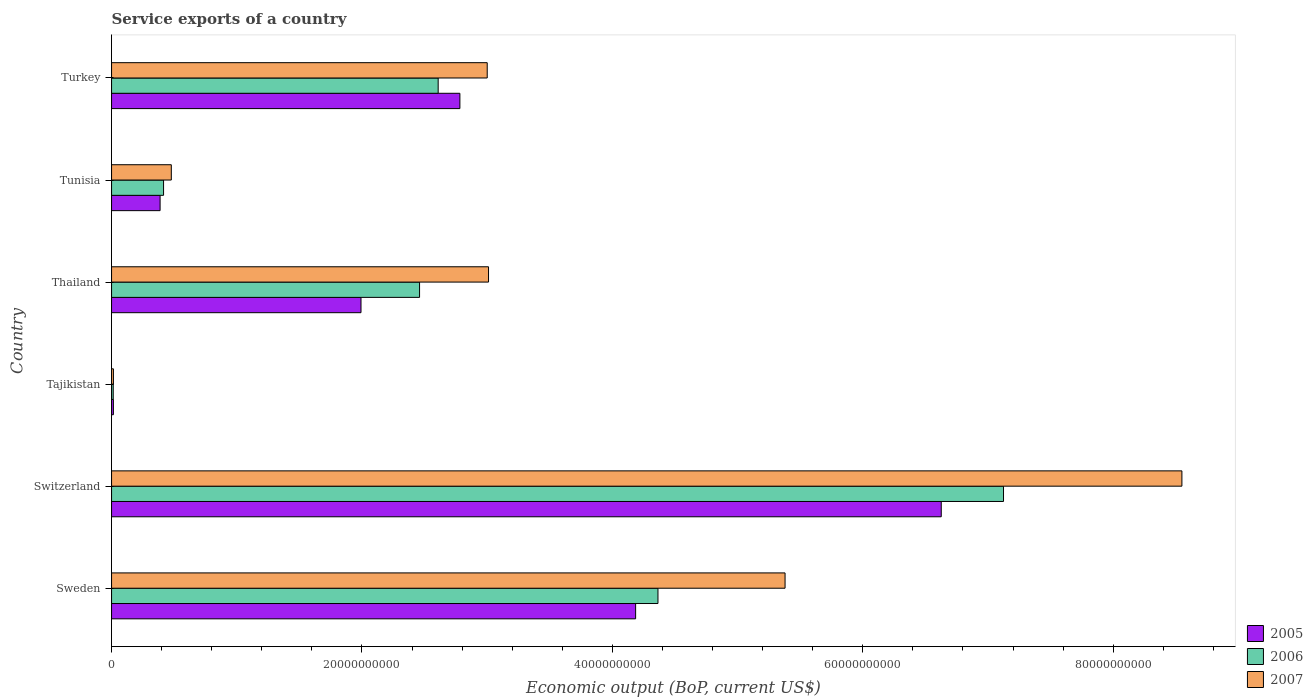How many groups of bars are there?
Give a very brief answer. 6. How many bars are there on the 5th tick from the top?
Keep it short and to the point. 3. What is the label of the 2nd group of bars from the top?
Provide a succinct answer. Tunisia. In how many cases, is the number of bars for a given country not equal to the number of legend labels?
Ensure brevity in your answer.  0. What is the service exports in 2006 in Thailand?
Offer a very short reply. 2.46e+1. Across all countries, what is the maximum service exports in 2006?
Your answer should be very brief. 7.12e+1. Across all countries, what is the minimum service exports in 2007?
Your answer should be very brief. 1.49e+08. In which country was the service exports in 2005 maximum?
Your answer should be compact. Switzerland. In which country was the service exports in 2007 minimum?
Your response must be concise. Tajikistan. What is the total service exports in 2006 in the graph?
Offer a terse response. 1.70e+11. What is the difference between the service exports in 2007 in Switzerland and that in Thailand?
Your response must be concise. 5.54e+1. What is the difference between the service exports in 2006 in Thailand and the service exports in 2007 in Tajikistan?
Give a very brief answer. 2.45e+1. What is the average service exports in 2006 per country?
Your answer should be very brief. 2.83e+1. What is the difference between the service exports in 2005 and service exports in 2006 in Tunisia?
Keep it short and to the point. -2.76e+08. In how many countries, is the service exports in 2005 greater than 28000000000 US$?
Give a very brief answer. 2. What is the ratio of the service exports in 2005 in Thailand to that in Turkey?
Your answer should be compact. 0.72. Is the service exports in 2007 in Tajikistan less than that in Tunisia?
Make the answer very short. Yes. Is the difference between the service exports in 2005 in Sweden and Tunisia greater than the difference between the service exports in 2006 in Sweden and Tunisia?
Offer a very short reply. No. What is the difference between the highest and the second highest service exports in 2005?
Your answer should be very brief. 2.44e+1. What is the difference between the highest and the lowest service exports in 2007?
Offer a terse response. 8.53e+1. In how many countries, is the service exports in 2006 greater than the average service exports in 2006 taken over all countries?
Your response must be concise. 2. What does the 2nd bar from the bottom in Sweden represents?
Give a very brief answer. 2006. Is it the case that in every country, the sum of the service exports in 2005 and service exports in 2007 is greater than the service exports in 2006?
Offer a very short reply. Yes. Does the graph contain grids?
Your answer should be very brief. No. How many legend labels are there?
Offer a terse response. 3. How are the legend labels stacked?
Give a very brief answer. Vertical. What is the title of the graph?
Offer a terse response. Service exports of a country. What is the label or title of the X-axis?
Ensure brevity in your answer.  Economic output (BoP, current US$). What is the label or title of the Y-axis?
Ensure brevity in your answer.  Country. What is the Economic output (BoP, current US$) of 2005 in Sweden?
Your answer should be compact. 4.19e+1. What is the Economic output (BoP, current US$) of 2006 in Sweden?
Provide a succinct answer. 4.36e+1. What is the Economic output (BoP, current US$) of 2007 in Sweden?
Give a very brief answer. 5.38e+1. What is the Economic output (BoP, current US$) of 2005 in Switzerland?
Offer a terse response. 6.63e+1. What is the Economic output (BoP, current US$) in 2006 in Switzerland?
Your response must be concise. 7.12e+1. What is the Economic output (BoP, current US$) in 2007 in Switzerland?
Your answer should be compact. 8.55e+1. What is the Economic output (BoP, current US$) of 2005 in Tajikistan?
Provide a succinct answer. 1.46e+08. What is the Economic output (BoP, current US$) in 2006 in Tajikistan?
Your response must be concise. 1.34e+08. What is the Economic output (BoP, current US$) in 2007 in Tajikistan?
Make the answer very short. 1.49e+08. What is the Economic output (BoP, current US$) of 2005 in Thailand?
Make the answer very short. 1.99e+1. What is the Economic output (BoP, current US$) of 2006 in Thailand?
Ensure brevity in your answer.  2.46e+1. What is the Economic output (BoP, current US$) of 2007 in Thailand?
Offer a terse response. 3.01e+1. What is the Economic output (BoP, current US$) in 2005 in Tunisia?
Give a very brief answer. 3.88e+09. What is the Economic output (BoP, current US$) in 2006 in Tunisia?
Ensure brevity in your answer.  4.15e+09. What is the Economic output (BoP, current US$) in 2007 in Tunisia?
Give a very brief answer. 4.77e+09. What is the Economic output (BoP, current US$) in 2005 in Turkey?
Ensure brevity in your answer.  2.78e+1. What is the Economic output (BoP, current US$) in 2006 in Turkey?
Your answer should be compact. 2.61e+1. What is the Economic output (BoP, current US$) in 2007 in Turkey?
Offer a very short reply. 3.00e+1. Across all countries, what is the maximum Economic output (BoP, current US$) of 2005?
Provide a succinct answer. 6.63e+1. Across all countries, what is the maximum Economic output (BoP, current US$) in 2006?
Offer a very short reply. 7.12e+1. Across all countries, what is the maximum Economic output (BoP, current US$) of 2007?
Ensure brevity in your answer.  8.55e+1. Across all countries, what is the minimum Economic output (BoP, current US$) of 2005?
Ensure brevity in your answer.  1.46e+08. Across all countries, what is the minimum Economic output (BoP, current US$) of 2006?
Provide a succinct answer. 1.34e+08. Across all countries, what is the minimum Economic output (BoP, current US$) of 2007?
Provide a succinct answer. 1.49e+08. What is the total Economic output (BoP, current US$) in 2005 in the graph?
Give a very brief answer. 1.60e+11. What is the total Economic output (BoP, current US$) in 2006 in the graph?
Offer a very short reply. 1.70e+11. What is the total Economic output (BoP, current US$) in 2007 in the graph?
Offer a terse response. 2.04e+11. What is the difference between the Economic output (BoP, current US$) in 2005 in Sweden and that in Switzerland?
Provide a short and direct response. -2.44e+1. What is the difference between the Economic output (BoP, current US$) in 2006 in Sweden and that in Switzerland?
Keep it short and to the point. -2.76e+1. What is the difference between the Economic output (BoP, current US$) of 2007 in Sweden and that in Switzerland?
Offer a very short reply. -3.17e+1. What is the difference between the Economic output (BoP, current US$) of 2005 in Sweden and that in Tajikistan?
Your answer should be very brief. 4.17e+1. What is the difference between the Economic output (BoP, current US$) of 2006 in Sweden and that in Tajikistan?
Offer a terse response. 4.35e+1. What is the difference between the Economic output (BoP, current US$) of 2007 in Sweden and that in Tajikistan?
Provide a succinct answer. 5.36e+1. What is the difference between the Economic output (BoP, current US$) of 2005 in Sweden and that in Thailand?
Your answer should be compact. 2.19e+1. What is the difference between the Economic output (BoP, current US$) of 2006 in Sweden and that in Thailand?
Your answer should be very brief. 1.90e+1. What is the difference between the Economic output (BoP, current US$) of 2007 in Sweden and that in Thailand?
Your answer should be very brief. 2.37e+1. What is the difference between the Economic output (BoP, current US$) of 2005 in Sweden and that in Tunisia?
Give a very brief answer. 3.80e+1. What is the difference between the Economic output (BoP, current US$) in 2006 in Sweden and that in Tunisia?
Make the answer very short. 3.95e+1. What is the difference between the Economic output (BoP, current US$) of 2007 in Sweden and that in Tunisia?
Make the answer very short. 4.90e+1. What is the difference between the Economic output (BoP, current US$) in 2005 in Sweden and that in Turkey?
Provide a succinct answer. 1.40e+1. What is the difference between the Economic output (BoP, current US$) of 2006 in Sweden and that in Turkey?
Offer a very short reply. 1.76e+1. What is the difference between the Economic output (BoP, current US$) of 2007 in Sweden and that in Turkey?
Your response must be concise. 2.38e+1. What is the difference between the Economic output (BoP, current US$) in 2005 in Switzerland and that in Tajikistan?
Give a very brief answer. 6.61e+1. What is the difference between the Economic output (BoP, current US$) in 2006 in Switzerland and that in Tajikistan?
Your answer should be very brief. 7.11e+1. What is the difference between the Economic output (BoP, current US$) in 2007 in Switzerland and that in Tajikistan?
Make the answer very short. 8.53e+1. What is the difference between the Economic output (BoP, current US$) of 2005 in Switzerland and that in Thailand?
Make the answer very short. 4.63e+1. What is the difference between the Economic output (BoP, current US$) in 2006 in Switzerland and that in Thailand?
Keep it short and to the point. 4.66e+1. What is the difference between the Economic output (BoP, current US$) in 2007 in Switzerland and that in Thailand?
Offer a terse response. 5.54e+1. What is the difference between the Economic output (BoP, current US$) of 2005 in Switzerland and that in Tunisia?
Offer a terse response. 6.24e+1. What is the difference between the Economic output (BoP, current US$) in 2006 in Switzerland and that in Tunisia?
Offer a terse response. 6.71e+1. What is the difference between the Economic output (BoP, current US$) in 2007 in Switzerland and that in Tunisia?
Give a very brief answer. 8.07e+1. What is the difference between the Economic output (BoP, current US$) of 2005 in Switzerland and that in Turkey?
Your response must be concise. 3.84e+1. What is the difference between the Economic output (BoP, current US$) of 2006 in Switzerland and that in Turkey?
Offer a very short reply. 4.52e+1. What is the difference between the Economic output (BoP, current US$) of 2007 in Switzerland and that in Turkey?
Your answer should be very brief. 5.55e+1. What is the difference between the Economic output (BoP, current US$) of 2005 in Tajikistan and that in Thailand?
Provide a succinct answer. -1.98e+1. What is the difference between the Economic output (BoP, current US$) in 2006 in Tajikistan and that in Thailand?
Offer a terse response. -2.45e+1. What is the difference between the Economic output (BoP, current US$) in 2007 in Tajikistan and that in Thailand?
Offer a very short reply. -3.00e+1. What is the difference between the Economic output (BoP, current US$) of 2005 in Tajikistan and that in Tunisia?
Provide a succinct answer. -3.73e+09. What is the difference between the Economic output (BoP, current US$) in 2006 in Tajikistan and that in Tunisia?
Ensure brevity in your answer.  -4.02e+09. What is the difference between the Economic output (BoP, current US$) in 2007 in Tajikistan and that in Tunisia?
Keep it short and to the point. -4.62e+09. What is the difference between the Economic output (BoP, current US$) in 2005 in Tajikistan and that in Turkey?
Your response must be concise. -2.77e+1. What is the difference between the Economic output (BoP, current US$) in 2006 in Tajikistan and that in Turkey?
Offer a terse response. -2.60e+1. What is the difference between the Economic output (BoP, current US$) in 2007 in Tajikistan and that in Turkey?
Offer a very short reply. -2.99e+1. What is the difference between the Economic output (BoP, current US$) in 2005 in Thailand and that in Tunisia?
Ensure brevity in your answer.  1.60e+1. What is the difference between the Economic output (BoP, current US$) of 2006 in Thailand and that in Tunisia?
Give a very brief answer. 2.04e+1. What is the difference between the Economic output (BoP, current US$) in 2007 in Thailand and that in Tunisia?
Ensure brevity in your answer.  2.53e+1. What is the difference between the Economic output (BoP, current US$) in 2005 in Thailand and that in Turkey?
Keep it short and to the point. -7.90e+09. What is the difference between the Economic output (BoP, current US$) of 2006 in Thailand and that in Turkey?
Provide a succinct answer. -1.49e+09. What is the difference between the Economic output (BoP, current US$) of 2007 in Thailand and that in Turkey?
Your response must be concise. 1.05e+08. What is the difference between the Economic output (BoP, current US$) of 2005 in Tunisia and that in Turkey?
Offer a terse response. -2.39e+1. What is the difference between the Economic output (BoP, current US$) of 2006 in Tunisia and that in Turkey?
Keep it short and to the point. -2.19e+1. What is the difference between the Economic output (BoP, current US$) of 2007 in Tunisia and that in Turkey?
Offer a very short reply. -2.52e+1. What is the difference between the Economic output (BoP, current US$) of 2005 in Sweden and the Economic output (BoP, current US$) of 2006 in Switzerland?
Give a very brief answer. -2.94e+1. What is the difference between the Economic output (BoP, current US$) in 2005 in Sweden and the Economic output (BoP, current US$) in 2007 in Switzerland?
Your response must be concise. -4.36e+1. What is the difference between the Economic output (BoP, current US$) of 2006 in Sweden and the Economic output (BoP, current US$) of 2007 in Switzerland?
Keep it short and to the point. -4.18e+1. What is the difference between the Economic output (BoP, current US$) in 2005 in Sweden and the Economic output (BoP, current US$) in 2006 in Tajikistan?
Offer a terse response. 4.17e+1. What is the difference between the Economic output (BoP, current US$) of 2005 in Sweden and the Economic output (BoP, current US$) of 2007 in Tajikistan?
Provide a succinct answer. 4.17e+1. What is the difference between the Economic output (BoP, current US$) in 2006 in Sweden and the Economic output (BoP, current US$) in 2007 in Tajikistan?
Make the answer very short. 4.35e+1. What is the difference between the Economic output (BoP, current US$) of 2005 in Sweden and the Economic output (BoP, current US$) of 2006 in Thailand?
Provide a short and direct response. 1.73e+1. What is the difference between the Economic output (BoP, current US$) of 2005 in Sweden and the Economic output (BoP, current US$) of 2007 in Thailand?
Provide a short and direct response. 1.17e+1. What is the difference between the Economic output (BoP, current US$) in 2006 in Sweden and the Economic output (BoP, current US$) in 2007 in Thailand?
Offer a very short reply. 1.35e+1. What is the difference between the Economic output (BoP, current US$) of 2005 in Sweden and the Economic output (BoP, current US$) of 2006 in Tunisia?
Offer a very short reply. 3.77e+1. What is the difference between the Economic output (BoP, current US$) of 2005 in Sweden and the Economic output (BoP, current US$) of 2007 in Tunisia?
Provide a succinct answer. 3.71e+1. What is the difference between the Economic output (BoP, current US$) of 2006 in Sweden and the Economic output (BoP, current US$) of 2007 in Tunisia?
Your answer should be compact. 3.89e+1. What is the difference between the Economic output (BoP, current US$) of 2005 in Sweden and the Economic output (BoP, current US$) of 2006 in Turkey?
Ensure brevity in your answer.  1.58e+1. What is the difference between the Economic output (BoP, current US$) of 2005 in Sweden and the Economic output (BoP, current US$) of 2007 in Turkey?
Ensure brevity in your answer.  1.19e+1. What is the difference between the Economic output (BoP, current US$) of 2006 in Sweden and the Economic output (BoP, current US$) of 2007 in Turkey?
Ensure brevity in your answer.  1.36e+1. What is the difference between the Economic output (BoP, current US$) in 2005 in Switzerland and the Economic output (BoP, current US$) in 2006 in Tajikistan?
Ensure brevity in your answer.  6.61e+1. What is the difference between the Economic output (BoP, current US$) of 2005 in Switzerland and the Economic output (BoP, current US$) of 2007 in Tajikistan?
Your answer should be very brief. 6.61e+1. What is the difference between the Economic output (BoP, current US$) in 2006 in Switzerland and the Economic output (BoP, current US$) in 2007 in Tajikistan?
Your answer should be very brief. 7.11e+1. What is the difference between the Economic output (BoP, current US$) in 2005 in Switzerland and the Economic output (BoP, current US$) in 2006 in Thailand?
Your answer should be very brief. 4.17e+1. What is the difference between the Economic output (BoP, current US$) of 2005 in Switzerland and the Economic output (BoP, current US$) of 2007 in Thailand?
Ensure brevity in your answer.  3.62e+1. What is the difference between the Economic output (BoP, current US$) in 2006 in Switzerland and the Economic output (BoP, current US$) in 2007 in Thailand?
Your response must be concise. 4.11e+1. What is the difference between the Economic output (BoP, current US$) of 2005 in Switzerland and the Economic output (BoP, current US$) of 2006 in Tunisia?
Provide a succinct answer. 6.21e+1. What is the difference between the Economic output (BoP, current US$) in 2005 in Switzerland and the Economic output (BoP, current US$) in 2007 in Tunisia?
Ensure brevity in your answer.  6.15e+1. What is the difference between the Economic output (BoP, current US$) in 2006 in Switzerland and the Economic output (BoP, current US$) in 2007 in Tunisia?
Ensure brevity in your answer.  6.65e+1. What is the difference between the Economic output (BoP, current US$) in 2005 in Switzerland and the Economic output (BoP, current US$) in 2006 in Turkey?
Your answer should be very brief. 4.02e+1. What is the difference between the Economic output (BoP, current US$) of 2005 in Switzerland and the Economic output (BoP, current US$) of 2007 in Turkey?
Give a very brief answer. 3.63e+1. What is the difference between the Economic output (BoP, current US$) in 2006 in Switzerland and the Economic output (BoP, current US$) in 2007 in Turkey?
Offer a terse response. 4.12e+1. What is the difference between the Economic output (BoP, current US$) of 2005 in Tajikistan and the Economic output (BoP, current US$) of 2006 in Thailand?
Keep it short and to the point. -2.45e+1. What is the difference between the Economic output (BoP, current US$) of 2005 in Tajikistan and the Economic output (BoP, current US$) of 2007 in Thailand?
Give a very brief answer. -3.00e+1. What is the difference between the Economic output (BoP, current US$) in 2006 in Tajikistan and the Economic output (BoP, current US$) in 2007 in Thailand?
Offer a terse response. -3.00e+1. What is the difference between the Economic output (BoP, current US$) of 2005 in Tajikistan and the Economic output (BoP, current US$) of 2006 in Tunisia?
Provide a short and direct response. -4.01e+09. What is the difference between the Economic output (BoP, current US$) of 2005 in Tajikistan and the Economic output (BoP, current US$) of 2007 in Tunisia?
Provide a succinct answer. -4.63e+09. What is the difference between the Economic output (BoP, current US$) of 2006 in Tajikistan and the Economic output (BoP, current US$) of 2007 in Tunisia?
Provide a succinct answer. -4.64e+09. What is the difference between the Economic output (BoP, current US$) in 2005 in Tajikistan and the Economic output (BoP, current US$) in 2006 in Turkey?
Provide a succinct answer. -2.59e+1. What is the difference between the Economic output (BoP, current US$) in 2005 in Tajikistan and the Economic output (BoP, current US$) in 2007 in Turkey?
Ensure brevity in your answer.  -2.99e+1. What is the difference between the Economic output (BoP, current US$) of 2006 in Tajikistan and the Economic output (BoP, current US$) of 2007 in Turkey?
Offer a terse response. -2.99e+1. What is the difference between the Economic output (BoP, current US$) of 2005 in Thailand and the Economic output (BoP, current US$) of 2006 in Tunisia?
Keep it short and to the point. 1.58e+1. What is the difference between the Economic output (BoP, current US$) in 2005 in Thailand and the Economic output (BoP, current US$) in 2007 in Tunisia?
Give a very brief answer. 1.52e+1. What is the difference between the Economic output (BoP, current US$) of 2006 in Thailand and the Economic output (BoP, current US$) of 2007 in Tunisia?
Provide a succinct answer. 1.98e+1. What is the difference between the Economic output (BoP, current US$) of 2005 in Thailand and the Economic output (BoP, current US$) of 2006 in Turkey?
Keep it short and to the point. -6.16e+09. What is the difference between the Economic output (BoP, current US$) in 2005 in Thailand and the Economic output (BoP, current US$) in 2007 in Turkey?
Ensure brevity in your answer.  -1.01e+1. What is the difference between the Economic output (BoP, current US$) of 2006 in Thailand and the Economic output (BoP, current US$) of 2007 in Turkey?
Make the answer very short. -5.40e+09. What is the difference between the Economic output (BoP, current US$) of 2005 in Tunisia and the Economic output (BoP, current US$) of 2006 in Turkey?
Offer a very short reply. -2.22e+1. What is the difference between the Economic output (BoP, current US$) of 2005 in Tunisia and the Economic output (BoP, current US$) of 2007 in Turkey?
Your answer should be compact. -2.61e+1. What is the difference between the Economic output (BoP, current US$) in 2006 in Tunisia and the Economic output (BoP, current US$) in 2007 in Turkey?
Provide a succinct answer. -2.59e+1. What is the average Economic output (BoP, current US$) in 2005 per country?
Keep it short and to the point. 2.66e+1. What is the average Economic output (BoP, current US$) of 2006 per country?
Give a very brief answer. 2.83e+1. What is the average Economic output (BoP, current US$) of 2007 per country?
Offer a very short reply. 3.41e+1. What is the difference between the Economic output (BoP, current US$) of 2005 and Economic output (BoP, current US$) of 2006 in Sweden?
Ensure brevity in your answer.  -1.78e+09. What is the difference between the Economic output (BoP, current US$) of 2005 and Economic output (BoP, current US$) of 2007 in Sweden?
Provide a short and direct response. -1.19e+1. What is the difference between the Economic output (BoP, current US$) of 2006 and Economic output (BoP, current US$) of 2007 in Sweden?
Ensure brevity in your answer.  -1.02e+1. What is the difference between the Economic output (BoP, current US$) in 2005 and Economic output (BoP, current US$) in 2006 in Switzerland?
Your answer should be compact. -4.97e+09. What is the difference between the Economic output (BoP, current US$) of 2005 and Economic output (BoP, current US$) of 2007 in Switzerland?
Your answer should be compact. -1.92e+1. What is the difference between the Economic output (BoP, current US$) in 2006 and Economic output (BoP, current US$) in 2007 in Switzerland?
Keep it short and to the point. -1.42e+1. What is the difference between the Economic output (BoP, current US$) in 2005 and Economic output (BoP, current US$) in 2006 in Tajikistan?
Give a very brief answer. 1.21e+07. What is the difference between the Economic output (BoP, current US$) of 2005 and Economic output (BoP, current US$) of 2007 in Tajikistan?
Offer a terse response. -2.35e+06. What is the difference between the Economic output (BoP, current US$) of 2006 and Economic output (BoP, current US$) of 2007 in Tajikistan?
Keep it short and to the point. -1.45e+07. What is the difference between the Economic output (BoP, current US$) in 2005 and Economic output (BoP, current US$) in 2006 in Thailand?
Your answer should be compact. -4.68e+09. What is the difference between the Economic output (BoP, current US$) in 2005 and Economic output (BoP, current US$) in 2007 in Thailand?
Your response must be concise. -1.02e+1. What is the difference between the Economic output (BoP, current US$) in 2006 and Economic output (BoP, current US$) in 2007 in Thailand?
Your response must be concise. -5.51e+09. What is the difference between the Economic output (BoP, current US$) in 2005 and Economic output (BoP, current US$) in 2006 in Tunisia?
Your response must be concise. -2.76e+08. What is the difference between the Economic output (BoP, current US$) of 2005 and Economic output (BoP, current US$) of 2007 in Tunisia?
Make the answer very short. -8.95e+08. What is the difference between the Economic output (BoP, current US$) in 2006 and Economic output (BoP, current US$) in 2007 in Tunisia?
Ensure brevity in your answer.  -6.19e+08. What is the difference between the Economic output (BoP, current US$) in 2005 and Economic output (BoP, current US$) in 2006 in Turkey?
Provide a succinct answer. 1.74e+09. What is the difference between the Economic output (BoP, current US$) in 2005 and Economic output (BoP, current US$) in 2007 in Turkey?
Your answer should be very brief. -2.18e+09. What is the difference between the Economic output (BoP, current US$) of 2006 and Economic output (BoP, current US$) of 2007 in Turkey?
Provide a succinct answer. -3.92e+09. What is the ratio of the Economic output (BoP, current US$) in 2005 in Sweden to that in Switzerland?
Offer a very short reply. 0.63. What is the ratio of the Economic output (BoP, current US$) in 2006 in Sweden to that in Switzerland?
Make the answer very short. 0.61. What is the ratio of the Economic output (BoP, current US$) in 2007 in Sweden to that in Switzerland?
Give a very brief answer. 0.63. What is the ratio of the Economic output (BoP, current US$) in 2005 in Sweden to that in Tajikistan?
Your answer should be very brief. 286.03. What is the ratio of the Economic output (BoP, current US$) in 2006 in Sweden to that in Tajikistan?
Provide a short and direct response. 325.17. What is the ratio of the Economic output (BoP, current US$) of 2007 in Sweden to that in Tajikistan?
Provide a succinct answer. 361.78. What is the ratio of the Economic output (BoP, current US$) of 2005 in Sweden to that in Thailand?
Offer a very short reply. 2.1. What is the ratio of the Economic output (BoP, current US$) of 2006 in Sweden to that in Thailand?
Provide a succinct answer. 1.77. What is the ratio of the Economic output (BoP, current US$) of 2007 in Sweden to that in Thailand?
Provide a short and direct response. 1.79. What is the ratio of the Economic output (BoP, current US$) of 2005 in Sweden to that in Tunisia?
Provide a succinct answer. 10.8. What is the ratio of the Economic output (BoP, current US$) in 2006 in Sweden to that in Tunisia?
Offer a terse response. 10.51. What is the ratio of the Economic output (BoP, current US$) of 2007 in Sweden to that in Tunisia?
Your answer should be compact. 11.27. What is the ratio of the Economic output (BoP, current US$) of 2005 in Sweden to that in Turkey?
Provide a succinct answer. 1.5. What is the ratio of the Economic output (BoP, current US$) in 2006 in Sweden to that in Turkey?
Provide a short and direct response. 1.67. What is the ratio of the Economic output (BoP, current US$) of 2007 in Sweden to that in Turkey?
Offer a very short reply. 1.79. What is the ratio of the Economic output (BoP, current US$) of 2005 in Switzerland to that in Tajikistan?
Your response must be concise. 452.84. What is the ratio of the Economic output (BoP, current US$) in 2006 in Switzerland to that in Tajikistan?
Ensure brevity in your answer.  530.8. What is the ratio of the Economic output (BoP, current US$) in 2007 in Switzerland to that in Tajikistan?
Your response must be concise. 574.95. What is the ratio of the Economic output (BoP, current US$) in 2005 in Switzerland to that in Thailand?
Offer a very short reply. 3.33. What is the ratio of the Economic output (BoP, current US$) of 2006 in Switzerland to that in Thailand?
Keep it short and to the point. 2.9. What is the ratio of the Economic output (BoP, current US$) in 2007 in Switzerland to that in Thailand?
Provide a succinct answer. 2.84. What is the ratio of the Economic output (BoP, current US$) in 2005 in Switzerland to that in Tunisia?
Provide a short and direct response. 17.09. What is the ratio of the Economic output (BoP, current US$) of 2006 in Switzerland to that in Tunisia?
Make the answer very short. 17.15. What is the ratio of the Economic output (BoP, current US$) in 2007 in Switzerland to that in Tunisia?
Make the answer very short. 17.91. What is the ratio of the Economic output (BoP, current US$) in 2005 in Switzerland to that in Turkey?
Offer a very short reply. 2.38. What is the ratio of the Economic output (BoP, current US$) in 2006 in Switzerland to that in Turkey?
Ensure brevity in your answer.  2.73. What is the ratio of the Economic output (BoP, current US$) in 2007 in Switzerland to that in Turkey?
Keep it short and to the point. 2.85. What is the ratio of the Economic output (BoP, current US$) in 2005 in Tajikistan to that in Thailand?
Keep it short and to the point. 0.01. What is the ratio of the Economic output (BoP, current US$) of 2006 in Tajikistan to that in Thailand?
Provide a succinct answer. 0.01. What is the ratio of the Economic output (BoP, current US$) in 2007 in Tajikistan to that in Thailand?
Give a very brief answer. 0. What is the ratio of the Economic output (BoP, current US$) in 2005 in Tajikistan to that in Tunisia?
Keep it short and to the point. 0.04. What is the ratio of the Economic output (BoP, current US$) in 2006 in Tajikistan to that in Tunisia?
Give a very brief answer. 0.03. What is the ratio of the Economic output (BoP, current US$) in 2007 in Tajikistan to that in Tunisia?
Ensure brevity in your answer.  0.03. What is the ratio of the Economic output (BoP, current US$) in 2005 in Tajikistan to that in Turkey?
Ensure brevity in your answer.  0.01. What is the ratio of the Economic output (BoP, current US$) of 2006 in Tajikistan to that in Turkey?
Your response must be concise. 0.01. What is the ratio of the Economic output (BoP, current US$) of 2007 in Tajikistan to that in Turkey?
Ensure brevity in your answer.  0.01. What is the ratio of the Economic output (BoP, current US$) of 2005 in Thailand to that in Tunisia?
Ensure brevity in your answer.  5.14. What is the ratio of the Economic output (BoP, current US$) in 2006 in Thailand to that in Tunisia?
Keep it short and to the point. 5.92. What is the ratio of the Economic output (BoP, current US$) in 2007 in Thailand to that in Tunisia?
Your answer should be compact. 6.31. What is the ratio of the Economic output (BoP, current US$) of 2005 in Thailand to that in Turkey?
Give a very brief answer. 0.72. What is the ratio of the Economic output (BoP, current US$) of 2006 in Thailand to that in Turkey?
Your answer should be very brief. 0.94. What is the ratio of the Economic output (BoP, current US$) of 2007 in Thailand to that in Turkey?
Your response must be concise. 1. What is the ratio of the Economic output (BoP, current US$) of 2005 in Tunisia to that in Turkey?
Provide a short and direct response. 0.14. What is the ratio of the Economic output (BoP, current US$) in 2006 in Tunisia to that in Turkey?
Offer a terse response. 0.16. What is the ratio of the Economic output (BoP, current US$) in 2007 in Tunisia to that in Turkey?
Your response must be concise. 0.16. What is the difference between the highest and the second highest Economic output (BoP, current US$) of 2005?
Ensure brevity in your answer.  2.44e+1. What is the difference between the highest and the second highest Economic output (BoP, current US$) of 2006?
Keep it short and to the point. 2.76e+1. What is the difference between the highest and the second highest Economic output (BoP, current US$) of 2007?
Provide a succinct answer. 3.17e+1. What is the difference between the highest and the lowest Economic output (BoP, current US$) in 2005?
Your response must be concise. 6.61e+1. What is the difference between the highest and the lowest Economic output (BoP, current US$) of 2006?
Keep it short and to the point. 7.11e+1. What is the difference between the highest and the lowest Economic output (BoP, current US$) of 2007?
Keep it short and to the point. 8.53e+1. 